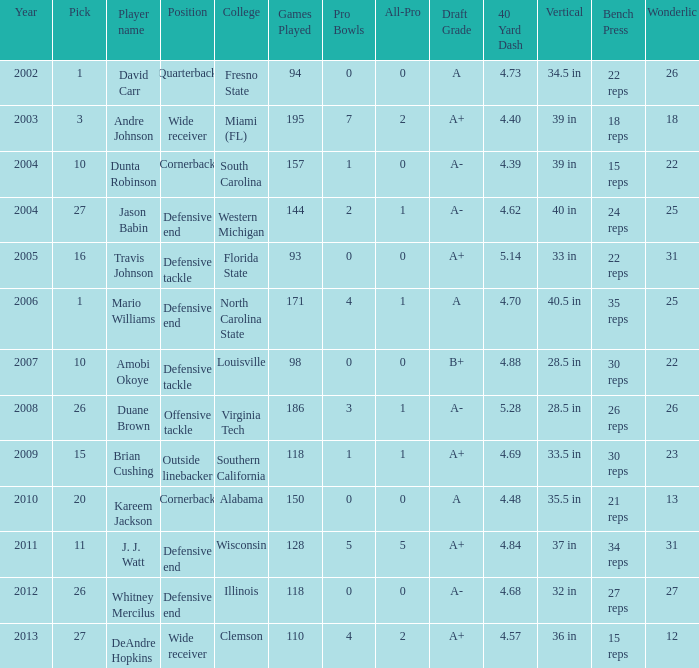What pick was mario williams before 2006? None. 